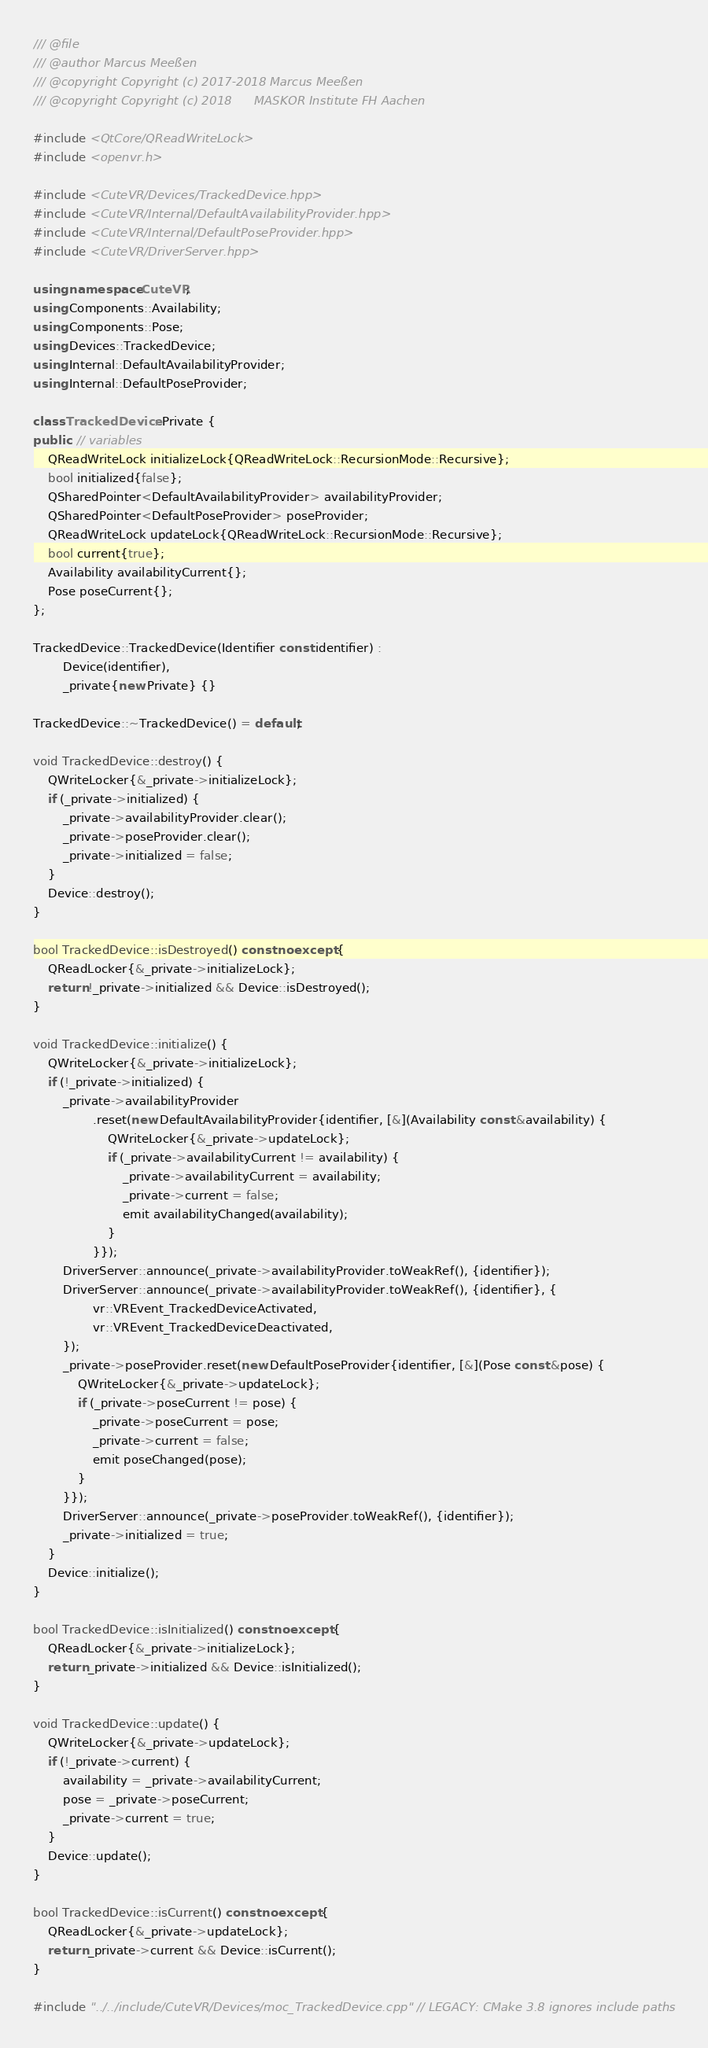Convert code to text. <code><loc_0><loc_0><loc_500><loc_500><_C++_>/// @file
/// @author Marcus Meeßen
/// @copyright Copyright (c) 2017-2018 Marcus Meeßen
/// @copyright Copyright (c) 2018      MASKOR Institute FH Aachen

#include <QtCore/QReadWriteLock>
#include <openvr.h>

#include <CuteVR/Devices/TrackedDevice.hpp>
#include <CuteVR/Internal/DefaultAvailabilityProvider.hpp>
#include <CuteVR/Internal/DefaultPoseProvider.hpp>
#include <CuteVR/DriverServer.hpp>

using namespace CuteVR;
using Components::Availability;
using Components::Pose;
using Devices::TrackedDevice;
using Internal::DefaultAvailabilityProvider;
using Internal::DefaultPoseProvider;

class TrackedDevice::Private {
public: // variables
    QReadWriteLock initializeLock{QReadWriteLock::RecursionMode::Recursive};
    bool initialized{false};
    QSharedPointer<DefaultAvailabilityProvider> availabilityProvider;
    QSharedPointer<DefaultPoseProvider> poseProvider;
    QReadWriteLock updateLock{QReadWriteLock::RecursionMode::Recursive};
    bool current{true};
    Availability availabilityCurrent{};
    Pose poseCurrent{};
};

TrackedDevice::TrackedDevice(Identifier const identifier) :
        Device(identifier),
        _private{new Private} {}

TrackedDevice::~TrackedDevice() = default;

void TrackedDevice::destroy() {
    QWriteLocker{&_private->initializeLock};
    if (_private->initialized) {
        _private->availabilityProvider.clear();
        _private->poseProvider.clear();
        _private->initialized = false;
    }
    Device::destroy();
}

bool TrackedDevice::isDestroyed() const noexcept {
    QReadLocker{&_private->initializeLock};
    return !_private->initialized && Device::isDestroyed();
}

void TrackedDevice::initialize() {
    QWriteLocker{&_private->initializeLock};
    if (!_private->initialized) {
        _private->availabilityProvider
                .reset(new DefaultAvailabilityProvider{identifier, [&](Availability const &availability) {
                    QWriteLocker{&_private->updateLock};
                    if (_private->availabilityCurrent != availability) {
                        _private->availabilityCurrent = availability;
                        _private->current = false;
                        emit availabilityChanged(availability);
                    }
                }});
        DriverServer::announce(_private->availabilityProvider.toWeakRef(), {identifier});
        DriverServer::announce(_private->availabilityProvider.toWeakRef(), {identifier}, {
                vr::VREvent_TrackedDeviceActivated,
                vr::VREvent_TrackedDeviceDeactivated,
        });
        _private->poseProvider.reset(new DefaultPoseProvider{identifier, [&](Pose const &pose) {
            QWriteLocker{&_private->updateLock};
            if (_private->poseCurrent != pose) {
                _private->poseCurrent = pose;
                _private->current = false;
                emit poseChanged(pose);
            }
        }});
        DriverServer::announce(_private->poseProvider.toWeakRef(), {identifier});
        _private->initialized = true;
    }
    Device::initialize();
}

bool TrackedDevice::isInitialized() const noexcept {
    QReadLocker{&_private->initializeLock};
    return _private->initialized && Device::isInitialized();
}

void TrackedDevice::update() {
    QWriteLocker{&_private->updateLock};
    if (!_private->current) {
        availability = _private->availabilityCurrent;
        pose = _private->poseCurrent;
        _private->current = true;
    }
    Device::update();
}

bool TrackedDevice::isCurrent() const noexcept {
    QReadLocker{&_private->updateLock};
    return _private->current && Device::isCurrent();
}

#include "../../include/CuteVR/Devices/moc_TrackedDevice.cpp" // LEGACY: CMake 3.8 ignores include paths
</code> 